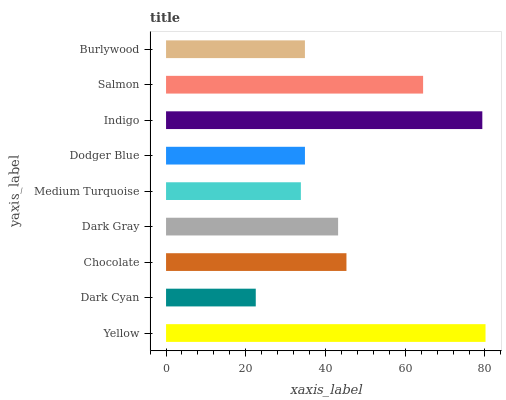Is Dark Cyan the minimum?
Answer yes or no. Yes. Is Yellow the maximum?
Answer yes or no. Yes. Is Chocolate the minimum?
Answer yes or no. No. Is Chocolate the maximum?
Answer yes or no. No. Is Chocolate greater than Dark Cyan?
Answer yes or no. Yes. Is Dark Cyan less than Chocolate?
Answer yes or no. Yes. Is Dark Cyan greater than Chocolate?
Answer yes or no. No. Is Chocolate less than Dark Cyan?
Answer yes or no. No. Is Dark Gray the high median?
Answer yes or no. Yes. Is Dark Gray the low median?
Answer yes or no. Yes. Is Salmon the high median?
Answer yes or no. No. Is Burlywood the low median?
Answer yes or no. No. 